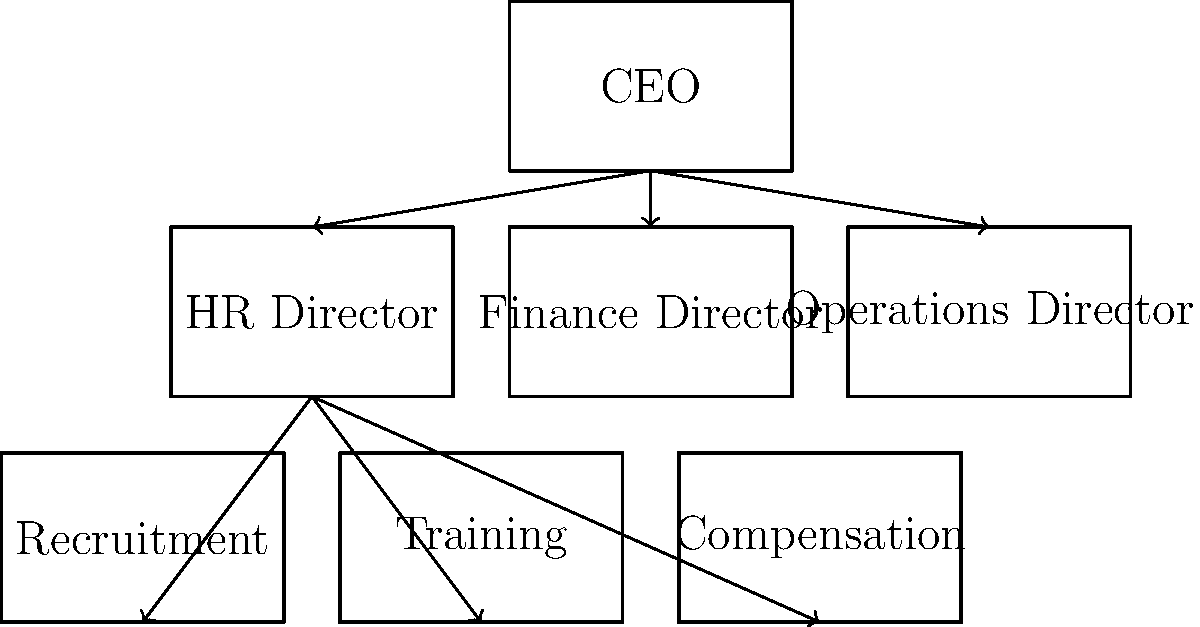In the organizational chart of this company's HR department, which division is not directly under the HR Director's supervision? To answer this question, we need to analyze the organizational chart step-by-step:

1. At the top of the chart, we see the CEO position.

2. Directly below the CEO, there are three director-level positions:
   - HR Director
   - Finance Director
   - Operations Director

3. Under the HR Director, we can see three divisions:
   - Recruitment
   - Training
   - Compensation

4. The Finance Director and Operations Director don't have any divisions shown under them in this chart.

5. By examining the lines and arrows, we can see that all three divisions (Recruitment, Training, and Compensation) are connected to the HR Director.

6. There are no other divisions or departments shown in the chart that are related to HR functions.

Therefore, all the HR-related divisions shown in the chart (Recruitment, Training, and Compensation) are directly under the HR Director's supervision. There is no HR division in this chart that is not under the HR Director's supervision.
Answer: None. All shown HR divisions are under the HR Director. 